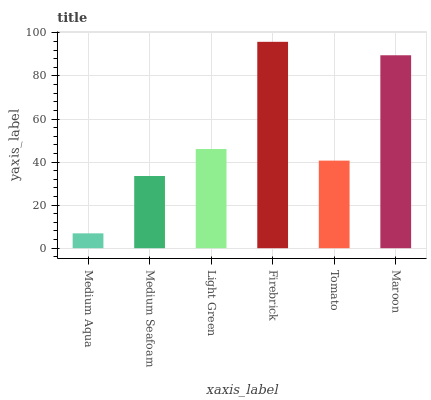Is Medium Seafoam the minimum?
Answer yes or no. No. Is Medium Seafoam the maximum?
Answer yes or no. No. Is Medium Seafoam greater than Medium Aqua?
Answer yes or no. Yes. Is Medium Aqua less than Medium Seafoam?
Answer yes or no. Yes. Is Medium Aqua greater than Medium Seafoam?
Answer yes or no. No. Is Medium Seafoam less than Medium Aqua?
Answer yes or no. No. Is Light Green the high median?
Answer yes or no. Yes. Is Tomato the low median?
Answer yes or no. Yes. Is Medium Seafoam the high median?
Answer yes or no. No. Is Maroon the low median?
Answer yes or no. No. 